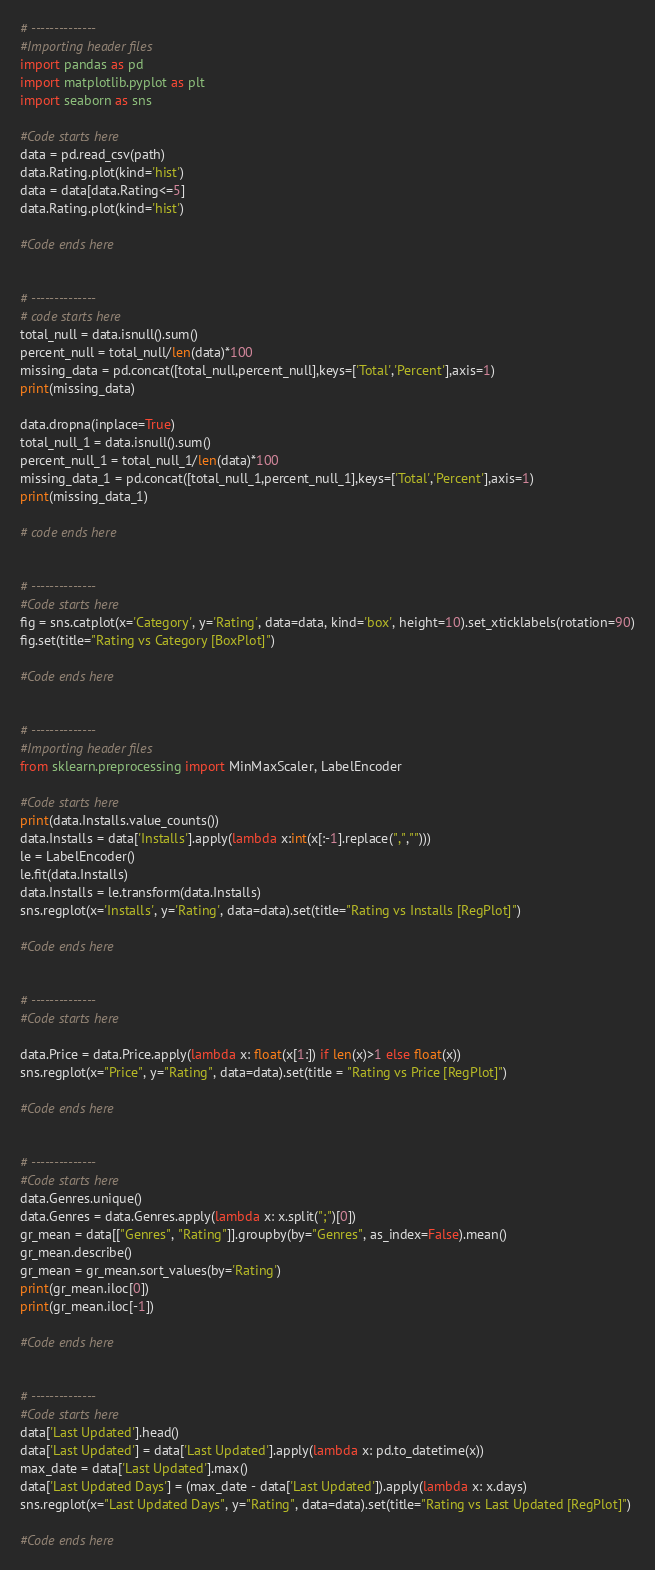<code> <loc_0><loc_0><loc_500><loc_500><_Python_># --------------
#Importing header files
import pandas as pd
import matplotlib.pyplot as plt
import seaborn as sns

#Code starts here
data = pd.read_csv(path)
data.Rating.plot(kind='hist')
data = data[data.Rating<=5]
data.Rating.plot(kind='hist')

#Code ends here


# --------------
# code starts here
total_null = data.isnull().sum()
percent_null = total_null/len(data)*100
missing_data = pd.concat([total_null,percent_null],keys=['Total','Percent'],axis=1)
print(missing_data)

data.dropna(inplace=True)
total_null_1 = data.isnull().sum()
percent_null_1 = total_null_1/len(data)*100
missing_data_1 = pd.concat([total_null_1,percent_null_1],keys=['Total','Percent'],axis=1)
print(missing_data_1)

# code ends here


# --------------
#Code starts here
fig = sns.catplot(x='Category', y='Rating', data=data, kind='box', height=10).set_xticklabels(rotation=90)
fig.set(title="Rating vs Category [BoxPlot]")

#Code ends here


# --------------
#Importing header files
from sklearn.preprocessing import MinMaxScaler, LabelEncoder

#Code starts here
print(data.Installs.value_counts())
data.Installs = data['Installs'].apply(lambda x:int(x[:-1].replace(",","")))
le = LabelEncoder()
le.fit(data.Installs)
data.Installs = le.transform(data.Installs)
sns.regplot(x='Installs', y='Rating', data=data).set(title="Rating vs Installs [RegPlot]")

#Code ends here


# --------------
#Code starts here

data.Price = data.Price.apply(lambda x: float(x[1:]) if len(x)>1 else float(x))
sns.regplot(x="Price", y="Rating", data=data).set(title = "Rating vs Price [RegPlot]")

#Code ends here


# --------------
#Code starts here
data.Genres.unique()
data.Genres = data.Genres.apply(lambda x: x.split(";")[0])
gr_mean = data[["Genres", "Rating"]].groupby(by="Genres", as_index=False).mean()
gr_mean.describe()
gr_mean = gr_mean.sort_values(by='Rating')
print(gr_mean.iloc[0])
print(gr_mean.iloc[-1])

#Code ends here


# --------------
#Code starts here
data['Last Updated'].head()
data['Last Updated'] = data['Last Updated'].apply(lambda x: pd.to_datetime(x))
max_date = data['Last Updated'].max()
data['Last Updated Days'] = (max_date - data['Last Updated']).apply(lambda x: x.days)
sns.regplot(x="Last Updated Days", y="Rating", data=data).set(title="Rating vs Last Updated [RegPlot]")

#Code ends here


</code> 